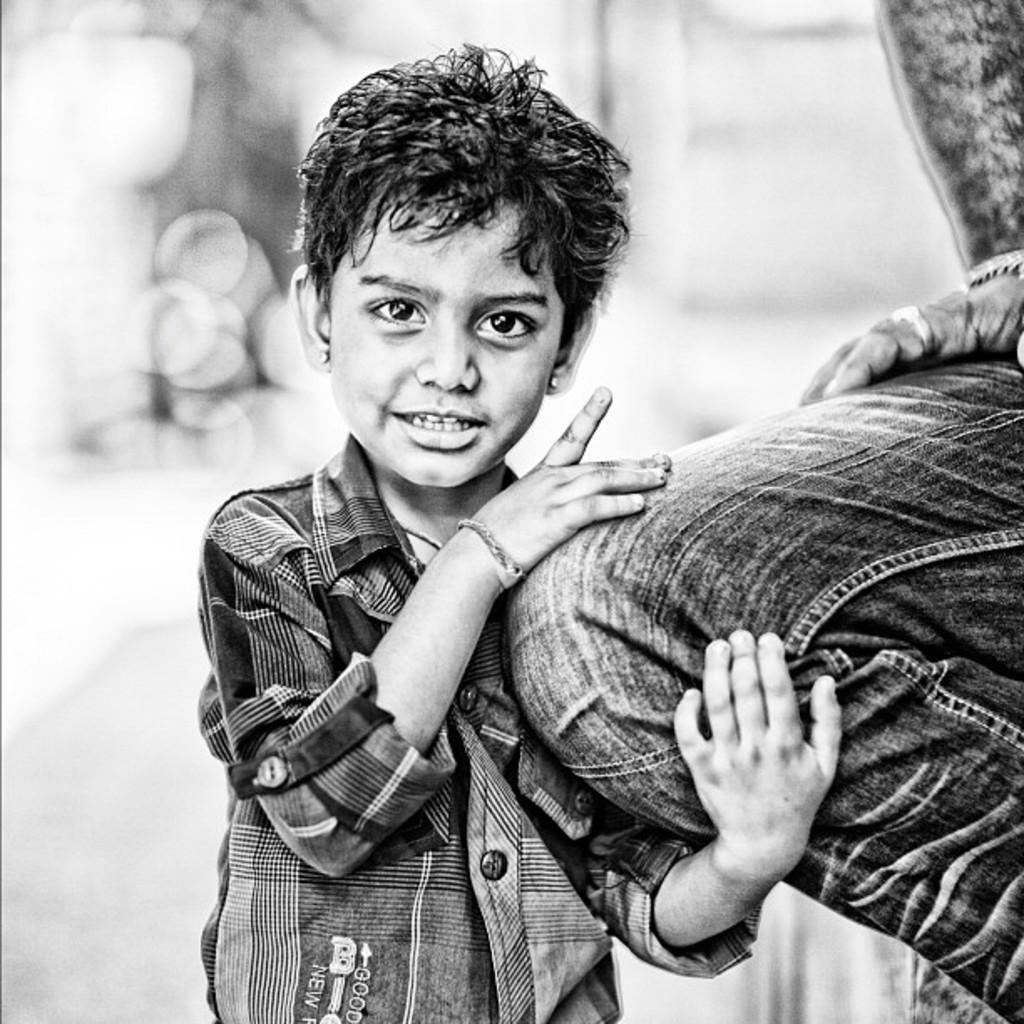Who is the main subject in the image? There is a boy in the image. Can you describe the other human in the image? There is a human on the right side of the image. How would you describe the background of the image? The background of the image is blurry. What color scheme is used in the image? The image is black and white. What type of carriage is being pulled by the boy in the image? There is no carriage present in the image; it features a boy and another human. How does the judge in the image react to the heat? There is no judge or heat mentioned in the image; it is a black and white image of a boy and another human with a blurry background. 